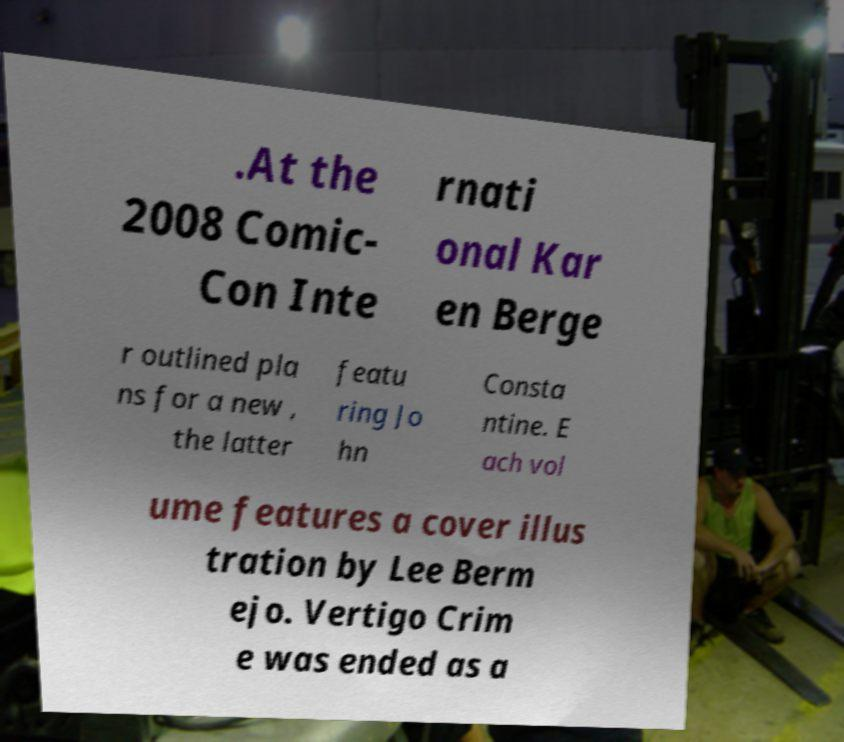Please read and relay the text visible in this image. What does it say? .At the 2008 Comic- Con Inte rnati onal Kar en Berge r outlined pla ns for a new , the latter featu ring Jo hn Consta ntine. E ach vol ume features a cover illus tration by Lee Berm ejo. Vertigo Crim e was ended as a 